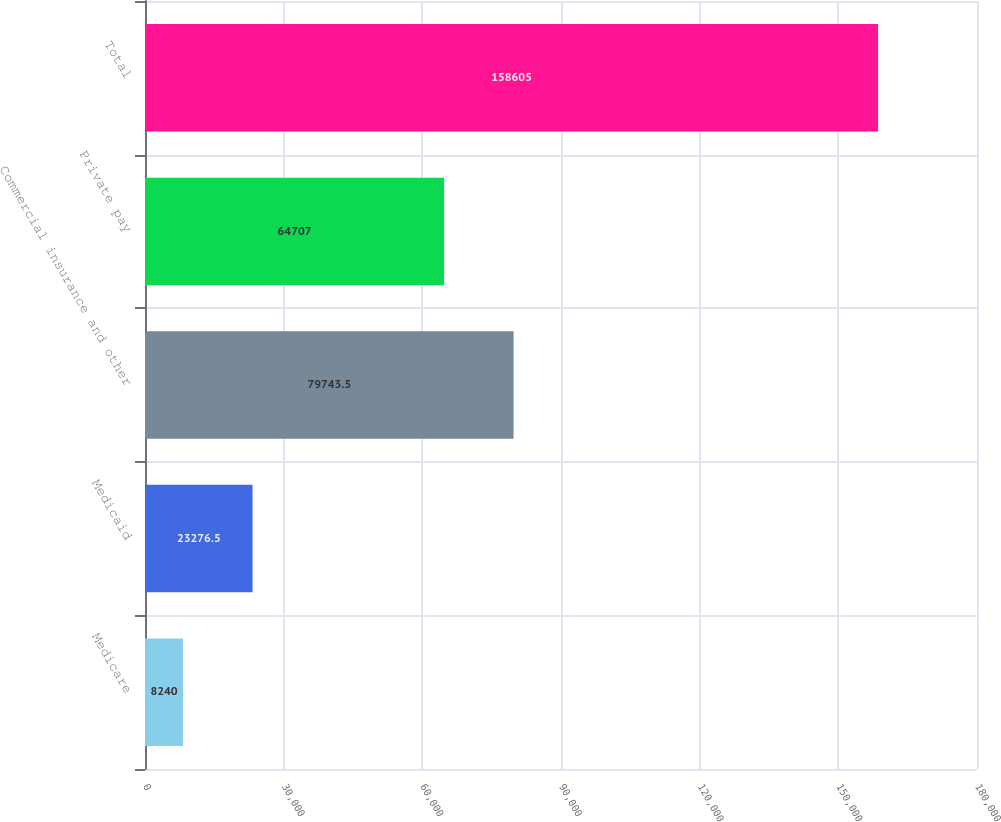Convert chart. <chart><loc_0><loc_0><loc_500><loc_500><bar_chart><fcel>Medicare<fcel>Medicaid<fcel>Commercial insurance and other<fcel>Private pay<fcel>Total<nl><fcel>8240<fcel>23276.5<fcel>79743.5<fcel>64707<fcel>158605<nl></chart> 